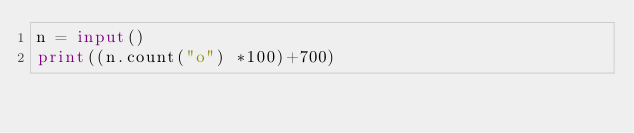<code> <loc_0><loc_0><loc_500><loc_500><_Python_>n = input()
print((n.count("o") *100)+700)</code> 